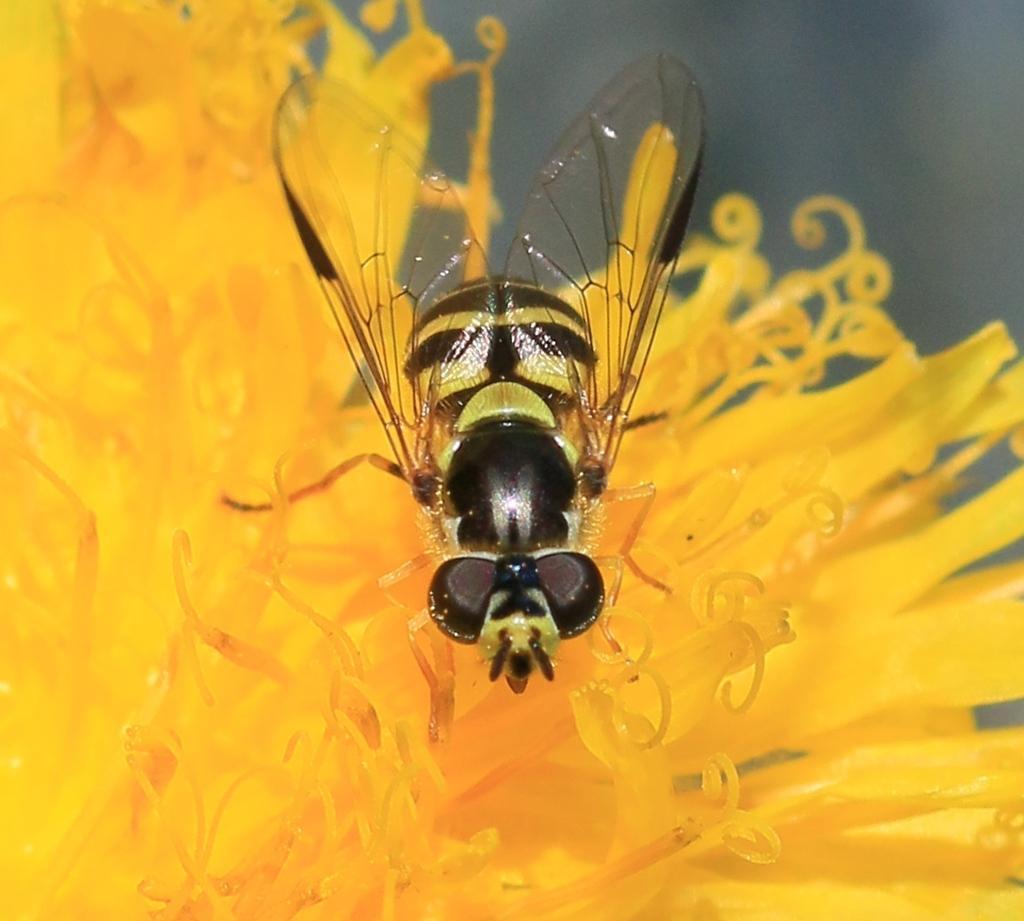Can you describe this image briefly? In this image, we can see honey bee on the yellow flower. 